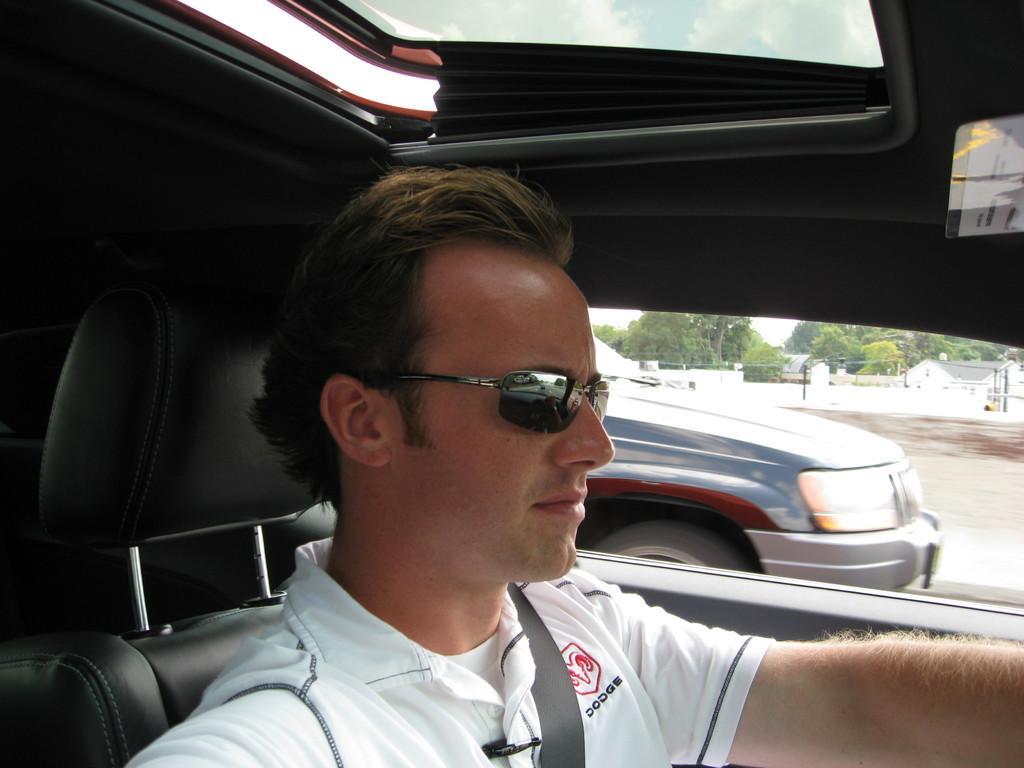In one or two sentences, can you explain what this image depicts? A person is riding in the car,through this car window we can see a vehicle,buildings,trees and sky. 